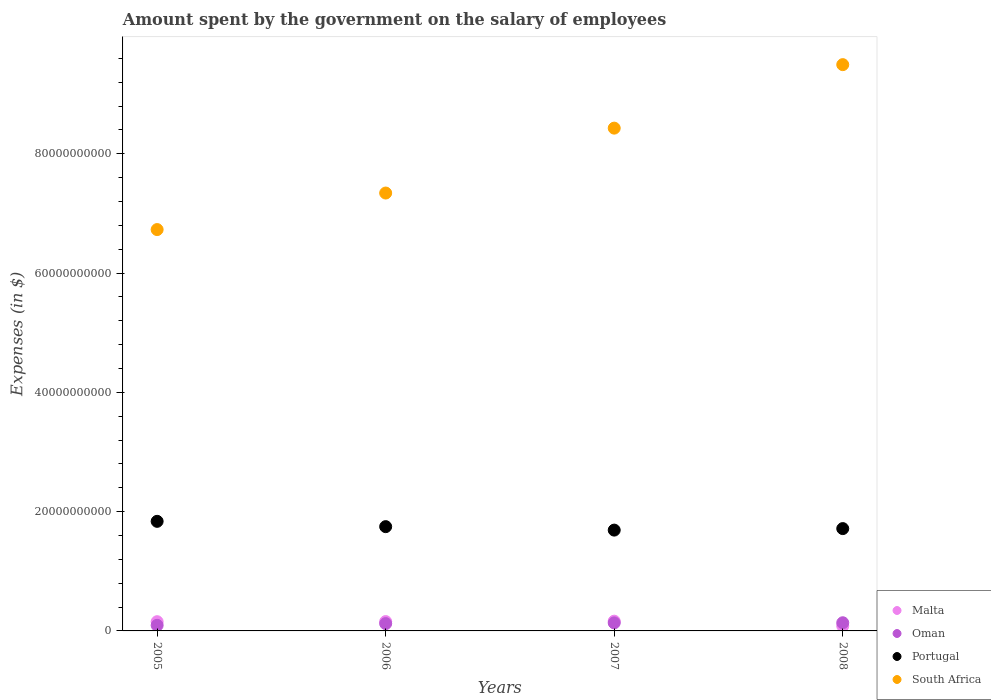What is the amount spent on the salary of employees by the government in Portugal in 2007?
Make the answer very short. 1.69e+1. Across all years, what is the maximum amount spent on the salary of employees by the government in Malta?
Your answer should be compact. 1.64e+09. Across all years, what is the minimum amount spent on the salary of employees by the government in Portugal?
Keep it short and to the point. 1.69e+1. In which year was the amount spent on the salary of employees by the government in South Africa minimum?
Keep it short and to the point. 2005. What is the total amount spent on the salary of employees by the government in Portugal in the graph?
Provide a short and direct response. 6.99e+1. What is the difference between the amount spent on the salary of employees by the government in Malta in 2006 and that in 2008?
Your response must be concise. 7.38e+08. What is the difference between the amount spent on the salary of employees by the government in South Africa in 2006 and the amount spent on the salary of employees by the government in Portugal in 2007?
Give a very brief answer. 5.65e+1. What is the average amount spent on the salary of employees by the government in Oman per year?
Ensure brevity in your answer.  1.22e+09. In the year 2008, what is the difference between the amount spent on the salary of employees by the government in Portugal and amount spent on the salary of employees by the government in Oman?
Your response must be concise. 1.58e+1. In how many years, is the amount spent on the salary of employees by the government in South Africa greater than 60000000000 $?
Offer a terse response. 4. What is the ratio of the amount spent on the salary of employees by the government in Malta in 2005 to that in 2006?
Your answer should be compact. 0.99. What is the difference between the highest and the second highest amount spent on the salary of employees by the government in Malta?
Your response must be concise. 7.19e+07. What is the difference between the highest and the lowest amount spent on the salary of employees by the government in South Africa?
Make the answer very short. 2.77e+1. In how many years, is the amount spent on the salary of employees by the government in Portugal greater than the average amount spent on the salary of employees by the government in Portugal taken over all years?
Ensure brevity in your answer.  2. Is the sum of the amount spent on the salary of employees by the government in South Africa in 2005 and 2008 greater than the maximum amount spent on the salary of employees by the government in Oman across all years?
Ensure brevity in your answer.  Yes. Is it the case that in every year, the sum of the amount spent on the salary of employees by the government in Malta and amount spent on the salary of employees by the government in South Africa  is greater than the sum of amount spent on the salary of employees by the government in Oman and amount spent on the salary of employees by the government in Portugal?
Provide a succinct answer. Yes. How many years are there in the graph?
Offer a terse response. 4. Does the graph contain any zero values?
Provide a succinct answer. No. What is the title of the graph?
Your answer should be very brief. Amount spent by the government on the salary of employees. Does "Puerto Rico" appear as one of the legend labels in the graph?
Keep it short and to the point. No. What is the label or title of the Y-axis?
Make the answer very short. Expenses (in $). What is the Expenses (in $) in Malta in 2005?
Offer a terse response. 1.55e+09. What is the Expenses (in $) of Oman in 2005?
Give a very brief answer. 9.38e+08. What is the Expenses (in $) in Portugal in 2005?
Your response must be concise. 1.84e+1. What is the Expenses (in $) of South Africa in 2005?
Your response must be concise. 6.73e+1. What is the Expenses (in $) in Malta in 2006?
Your response must be concise. 1.57e+09. What is the Expenses (in $) in Oman in 2006?
Keep it short and to the point. 1.23e+09. What is the Expenses (in $) of Portugal in 2006?
Make the answer very short. 1.75e+1. What is the Expenses (in $) of South Africa in 2006?
Keep it short and to the point. 7.34e+1. What is the Expenses (in $) of Malta in 2007?
Offer a very short reply. 1.64e+09. What is the Expenses (in $) in Oman in 2007?
Your response must be concise. 1.35e+09. What is the Expenses (in $) in Portugal in 2007?
Ensure brevity in your answer.  1.69e+1. What is the Expenses (in $) of South Africa in 2007?
Your response must be concise. 8.43e+1. What is the Expenses (in $) of Malta in 2008?
Your answer should be compact. 8.27e+08. What is the Expenses (in $) of Oman in 2008?
Provide a short and direct response. 1.37e+09. What is the Expenses (in $) in Portugal in 2008?
Make the answer very short. 1.72e+1. What is the Expenses (in $) of South Africa in 2008?
Your answer should be very brief. 9.49e+1. Across all years, what is the maximum Expenses (in $) of Malta?
Make the answer very short. 1.64e+09. Across all years, what is the maximum Expenses (in $) of Oman?
Provide a succinct answer. 1.37e+09. Across all years, what is the maximum Expenses (in $) of Portugal?
Keep it short and to the point. 1.84e+1. Across all years, what is the maximum Expenses (in $) in South Africa?
Provide a short and direct response. 9.49e+1. Across all years, what is the minimum Expenses (in $) of Malta?
Make the answer very short. 8.27e+08. Across all years, what is the minimum Expenses (in $) in Oman?
Your answer should be very brief. 9.38e+08. Across all years, what is the minimum Expenses (in $) of Portugal?
Offer a terse response. 1.69e+1. Across all years, what is the minimum Expenses (in $) of South Africa?
Your answer should be very brief. 6.73e+1. What is the total Expenses (in $) of Malta in the graph?
Your answer should be very brief. 5.58e+09. What is the total Expenses (in $) of Oman in the graph?
Make the answer very short. 4.88e+09. What is the total Expenses (in $) of Portugal in the graph?
Make the answer very short. 6.99e+1. What is the total Expenses (in $) of South Africa in the graph?
Offer a very short reply. 3.20e+11. What is the difference between the Expenses (in $) of Malta in 2005 and that in 2006?
Provide a short and direct response. -1.82e+07. What is the difference between the Expenses (in $) of Oman in 2005 and that in 2006?
Your answer should be compact. -2.89e+08. What is the difference between the Expenses (in $) of Portugal in 2005 and that in 2006?
Offer a very short reply. 8.90e+08. What is the difference between the Expenses (in $) of South Africa in 2005 and that in 2006?
Your answer should be compact. -6.12e+09. What is the difference between the Expenses (in $) in Malta in 2005 and that in 2007?
Your response must be concise. -9.01e+07. What is the difference between the Expenses (in $) in Oman in 2005 and that in 2007?
Offer a very short reply. -4.10e+08. What is the difference between the Expenses (in $) in Portugal in 2005 and that in 2007?
Your answer should be compact. 1.47e+09. What is the difference between the Expenses (in $) of South Africa in 2005 and that in 2007?
Provide a short and direct response. -1.70e+1. What is the difference between the Expenses (in $) in Malta in 2005 and that in 2008?
Ensure brevity in your answer.  7.20e+08. What is the difference between the Expenses (in $) of Oman in 2005 and that in 2008?
Provide a short and direct response. -4.31e+08. What is the difference between the Expenses (in $) in Portugal in 2005 and that in 2008?
Your answer should be compact. 1.22e+09. What is the difference between the Expenses (in $) of South Africa in 2005 and that in 2008?
Give a very brief answer. -2.77e+1. What is the difference between the Expenses (in $) of Malta in 2006 and that in 2007?
Ensure brevity in your answer.  -7.19e+07. What is the difference between the Expenses (in $) of Oman in 2006 and that in 2007?
Provide a short and direct response. -1.20e+08. What is the difference between the Expenses (in $) of Portugal in 2006 and that in 2007?
Keep it short and to the point. 5.80e+08. What is the difference between the Expenses (in $) of South Africa in 2006 and that in 2007?
Your response must be concise. -1.09e+1. What is the difference between the Expenses (in $) in Malta in 2006 and that in 2008?
Ensure brevity in your answer.  7.38e+08. What is the difference between the Expenses (in $) in Oman in 2006 and that in 2008?
Provide a short and direct response. -1.42e+08. What is the difference between the Expenses (in $) of Portugal in 2006 and that in 2008?
Give a very brief answer. 3.27e+08. What is the difference between the Expenses (in $) in South Africa in 2006 and that in 2008?
Provide a succinct answer. -2.15e+1. What is the difference between the Expenses (in $) of Malta in 2007 and that in 2008?
Your answer should be compact. 8.10e+08. What is the difference between the Expenses (in $) in Oman in 2007 and that in 2008?
Provide a succinct answer. -2.13e+07. What is the difference between the Expenses (in $) of Portugal in 2007 and that in 2008?
Ensure brevity in your answer.  -2.54e+08. What is the difference between the Expenses (in $) in South Africa in 2007 and that in 2008?
Keep it short and to the point. -1.06e+1. What is the difference between the Expenses (in $) in Malta in 2005 and the Expenses (in $) in Oman in 2006?
Your response must be concise. 3.19e+08. What is the difference between the Expenses (in $) in Malta in 2005 and the Expenses (in $) in Portugal in 2006?
Your response must be concise. -1.59e+1. What is the difference between the Expenses (in $) in Malta in 2005 and the Expenses (in $) in South Africa in 2006?
Your response must be concise. -7.19e+1. What is the difference between the Expenses (in $) in Oman in 2005 and the Expenses (in $) in Portugal in 2006?
Provide a succinct answer. -1.65e+1. What is the difference between the Expenses (in $) in Oman in 2005 and the Expenses (in $) in South Africa in 2006?
Provide a succinct answer. -7.25e+1. What is the difference between the Expenses (in $) of Portugal in 2005 and the Expenses (in $) of South Africa in 2006?
Ensure brevity in your answer.  -5.50e+1. What is the difference between the Expenses (in $) of Malta in 2005 and the Expenses (in $) of Oman in 2007?
Your answer should be compact. 1.99e+08. What is the difference between the Expenses (in $) of Malta in 2005 and the Expenses (in $) of Portugal in 2007?
Give a very brief answer. -1.54e+1. What is the difference between the Expenses (in $) of Malta in 2005 and the Expenses (in $) of South Africa in 2007?
Your answer should be very brief. -8.27e+1. What is the difference between the Expenses (in $) in Oman in 2005 and the Expenses (in $) in Portugal in 2007?
Provide a short and direct response. -1.60e+1. What is the difference between the Expenses (in $) in Oman in 2005 and the Expenses (in $) in South Africa in 2007?
Make the answer very short. -8.34e+1. What is the difference between the Expenses (in $) in Portugal in 2005 and the Expenses (in $) in South Africa in 2007?
Keep it short and to the point. -6.59e+1. What is the difference between the Expenses (in $) of Malta in 2005 and the Expenses (in $) of Oman in 2008?
Your response must be concise. 1.78e+08. What is the difference between the Expenses (in $) of Malta in 2005 and the Expenses (in $) of Portugal in 2008?
Your response must be concise. -1.56e+1. What is the difference between the Expenses (in $) of Malta in 2005 and the Expenses (in $) of South Africa in 2008?
Your answer should be very brief. -9.34e+1. What is the difference between the Expenses (in $) of Oman in 2005 and the Expenses (in $) of Portugal in 2008?
Ensure brevity in your answer.  -1.62e+1. What is the difference between the Expenses (in $) in Oman in 2005 and the Expenses (in $) in South Africa in 2008?
Offer a terse response. -9.40e+1. What is the difference between the Expenses (in $) of Portugal in 2005 and the Expenses (in $) of South Africa in 2008?
Offer a terse response. -7.66e+1. What is the difference between the Expenses (in $) in Malta in 2006 and the Expenses (in $) in Oman in 2007?
Ensure brevity in your answer.  2.17e+08. What is the difference between the Expenses (in $) of Malta in 2006 and the Expenses (in $) of Portugal in 2007?
Your answer should be compact. -1.53e+1. What is the difference between the Expenses (in $) in Malta in 2006 and the Expenses (in $) in South Africa in 2007?
Ensure brevity in your answer.  -8.27e+1. What is the difference between the Expenses (in $) in Oman in 2006 and the Expenses (in $) in Portugal in 2007?
Offer a very short reply. -1.57e+1. What is the difference between the Expenses (in $) of Oman in 2006 and the Expenses (in $) of South Africa in 2007?
Offer a terse response. -8.31e+1. What is the difference between the Expenses (in $) of Portugal in 2006 and the Expenses (in $) of South Africa in 2007?
Provide a short and direct response. -6.68e+1. What is the difference between the Expenses (in $) of Malta in 2006 and the Expenses (in $) of Oman in 2008?
Provide a short and direct response. 1.96e+08. What is the difference between the Expenses (in $) of Malta in 2006 and the Expenses (in $) of Portugal in 2008?
Provide a short and direct response. -1.56e+1. What is the difference between the Expenses (in $) of Malta in 2006 and the Expenses (in $) of South Africa in 2008?
Offer a very short reply. -9.34e+1. What is the difference between the Expenses (in $) of Oman in 2006 and the Expenses (in $) of Portugal in 2008?
Offer a very short reply. -1.59e+1. What is the difference between the Expenses (in $) of Oman in 2006 and the Expenses (in $) of South Africa in 2008?
Your response must be concise. -9.37e+1. What is the difference between the Expenses (in $) in Portugal in 2006 and the Expenses (in $) in South Africa in 2008?
Offer a terse response. -7.75e+1. What is the difference between the Expenses (in $) in Malta in 2007 and the Expenses (in $) in Oman in 2008?
Provide a succinct answer. 2.68e+08. What is the difference between the Expenses (in $) of Malta in 2007 and the Expenses (in $) of Portugal in 2008?
Offer a very short reply. -1.55e+1. What is the difference between the Expenses (in $) in Malta in 2007 and the Expenses (in $) in South Africa in 2008?
Ensure brevity in your answer.  -9.33e+1. What is the difference between the Expenses (in $) of Oman in 2007 and the Expenses (in $) of Portugal in 2008?
Your answer should be compact. -1.58e+1. What is the difference between the Expenses (in $) of Oman in 2007 and the Expenses (in $) of South Africa in 2008?
Make the answer very short. -9.36e+1. What is the difference between the Expenses (in $) of Portugal in 2007 and the Expenses (in $) of South Africa in 2008?
Give a very brief answer. -7.80e+1. What is the average Expenses (in $) of Malta per year?
Offer a terse response. 1.39e+09. What is the average Expenses (in $) of Oman per year?
Provide a short and direct response. 1.22e+09. What is the average Expenses (in $) of Portugal per year?
Offer a very short reply. 1.75e+1. What is the average Expenses (in $) in South Africa per year?
Offer a terse response. 8.00e+1. In the year 2005, what is the difference between the Expenses (in $) of Malta and Expenses (in $) of Oman?
Your response must be concise. 6.09e+08. In the year 2005, what is the difference between the Expenses (in $) of Malta and Expenses (in $) of Portugal?
Give a very brief answer. -1.68e+1. In the year 2005, what is the difference between the Expenses (in $) in Malta and Expenses (in $) in South Africa?
Your answer should be compact. -6.57e+1. In the year 2005, what is the difference between the Expenses (in $) in Oman and Expenses (in $) in Portugal?
Provide a short and direct response. -1.74e+1. In the year 2005, what is the difference between the Expenses (in $) of Oman and Expenses (in $) of South Africa?
Give a very brief answer. -6.63e+1. In the year 2005, what is the difference between the Expenses (in $) in Portugal and Expenses (in $) in South Africa?
Give a very brief answer. -4.89e+1. In the year 2006, what is the difference between the Expenses (in $) of Malta and Expenses (in $) of Oman?
Your answer should be compact. 3.38e+08. In the year 2006, what is the difference between the Expenses (in $) in Malta and Expenses (in $) in Portugal?
Provide a short and direct response. -1.59e+1. In the year 2006, what is the difference between the Expenses (in $) of Malta and Expenses (in $) of South Africa?
Offer a very short reply. -7.18e+1. In the year 2006, what is the difference between the Expenses (in $) in Oman and Expenses (in $) in Portugal?
Offer a very short reply. -1.63e+1. In the year 2006, what is the difference between the Expenses (in $) of Oman and Expenses (in $) of South Africa?
Make the answer very short. -7.22e+1. In the year 2006, what is the difference between the Expenses (in $) of Portugal and Expenses (in $) of South Africa?
Your answer should be very brief. -5.59e+1. In the year 2007, what is the difference between the Expenses (in $) in Malta and Expenses (in $) in Oman?
Ensure brevity in your answer.  2.89e+08. In the year 2007, what is the difference between the Expenses (in $) in Malta and Expenses (in $) in Portugal?
Your response must be concise. -1.53e+1. In the year 2007, what is the difference between the Expenses (in $) of Malta and Expenses (in $) of South Africa?
Provide a short and direct response. -8.27e+1. In the year 2007, what is the difference between the Expenses (in $) in Oman and Expenses (in $) in Portugal?
Offer a very short reply. -1.56e+1. In the year 2007, what is the difference between the Expenses (in $) of Oman and Expenses (in $) of South Africa?
Your answer should be very brief. -8.29e+1. In the year 2007, what is the difference between the Expenses (in $) in Portugal and Expenses (in $) in South Africa?
Offer a terse response. -6.74e+1. In the year 2008, what is the difference between the Expenses (in $) in Malta and Expenses (in $) in Oman?
Offer a very short reply. -5.42e+08. In the year 2008, what is the difference between the Expenses (in $) in Malta and Expenses (in $) in Portugal?
Offer a terse response. -1.63e+1. In the year 2008, what is the difference between the Expenses (in $) of Malta and Expenses (in $) of South Africa?
Offer a terse response. -9.41e+1. In the year 2008, what is the difference between the Expenses (in $) of Oman and Expenses (in $) of Portugal?
Give a very brief answer. -1.58e+1. In the year 2008, what is the difference between the Expenses (in $) in Oman and Expenses (in $) in South Africa?
Provide a short and direct response. -9.36e+1. In the year 2008, what is the difference between the Expenses (in $) in Portugal and Expenses (in $) in South Africa?
Provide a short and direct response. -7.78e+1. What is the ratio of the Expenses (in $) of Malta in 2005 to that in 2006?
Your answer should be compact. 0.99. What is the ratio of the Expenses (in $) of Oman in 2005 to that in 2006?
Give a very brief answer. 0.76. What is the ratio of the Expenses (in $) in Portugal in 2005 to that in 2006?
Provide a succinct answer. 1.05. What is the ratio of the Expenses (in $) in South Africa in 2005 to that in 2006?
Make the answer very short. 0.92. What is the ratio of the Expenses (in $) of Malta in 2005 to that in 2007?
Provide a short and direct response. 0.94. What is the ratio of the Expenses (in $) in Oman in 2005 to that in 2007?
Keep it short and to the point. 0.7. What is the ratio of the Expenses (in $) in Portugal in 2005 to that in 2007?
Give a very brief answer. 1.09. What is the ratio of the Expenses (in $) of South Africa in 2005 to that in 2007?
Your answer should be compact. 0.8. What is the ratio of the Expenses (in $) of Malta in 2005 to that in 2008?
Your answer should be very brief. 1.87. What is the ratio of the Expenses (in $) of Oman in 2005 to that in 2008?
Keep it short and to the point. 0.69. What is the ratio of the Expenses (in $) of Portugal in 2005 to that in 2008?
Ensure brevity in your answer.  1.07. What is the ratio of the Expenses (in $) in South Africa in 2005 to that in 2008?
Provide a short and direct response. 0.71. What is the ratio of the Expenses (in $) of Malta in 2006 to that in 2007?
Offer a very short reply. 0.96. What is the ratio of the Expenses (in $) in Oman in 2006 to that in 2007?
Provide a succinct answer. 0.91. What is the ratio of the Expenses (in $) in Portugal in 2006 to that in 2007?
Provide a succinct answer. 1.03. What is the ratio of the Expenses (in $) in South Africa in 2006 to that in 2007?
Keep it short and to the point. 0.87. What is the ratio of the Expenses (in $) in Malta in 2006 to that in 2008?
Offer a very short reply. 1.89. What is the ratio of the Expenses (in $) in Oman in 2006 to that in 2008?
Your response must be concise. 0.9. What is the ratio of the Expenses (in $) of South Africa in 2006 to that in 2008?
Offer a terse response. 0.77. What is the ratio of the Expenses (in $) of Malta in 2007 to that in 2008?
Ensure brevity in your answer.  1.98. What is the ratio of the Expenses (in $) of Oman in 2007 to that in 2008?
Your response must be concise. 0.98. What is the ratio of the Expenses (in $) of Portugal in 2007 to that in 2008?
Keep it short and to the point. 0.99. What is the ratio of the Expenses (in $) of South Africa in 2007 to that in 2008?
Offer a very short reply. 0.89. What is the difference between the highest and the second highest Expenses (in $) in Malta?
Make the answer very short. 7.19e+07. What is the difference between the highest and the second highest Expenses (in $) of Oman?
Your answer should be very brief. 2.13e+07. What is the difference between the highest and the second highest Expenses (in $) in Portugal?
Offer a terse response. 8.90e+08. What is the difference between the highest and the second highest Expenses (in $) in South Africa?
Make the answer very short. 1.06e+1. What is the difference between the highest and the lowest Expenses (in $) of Malta?
Keep it short and to the point. 8.10e+08. What is the difference between the highest and the lowest Expenses (in $) in Oman?
Ensure brevity in your answer.  4.31e+08. What is the difference between the highest and the lowest Expenses (in $) in Portugal?
Offer a very short reply. 1.47e+09. What is the difference between the highest and the lowest Expenses (in $) of South Africa?
Provide a short and direct response. 2.77e+1. 